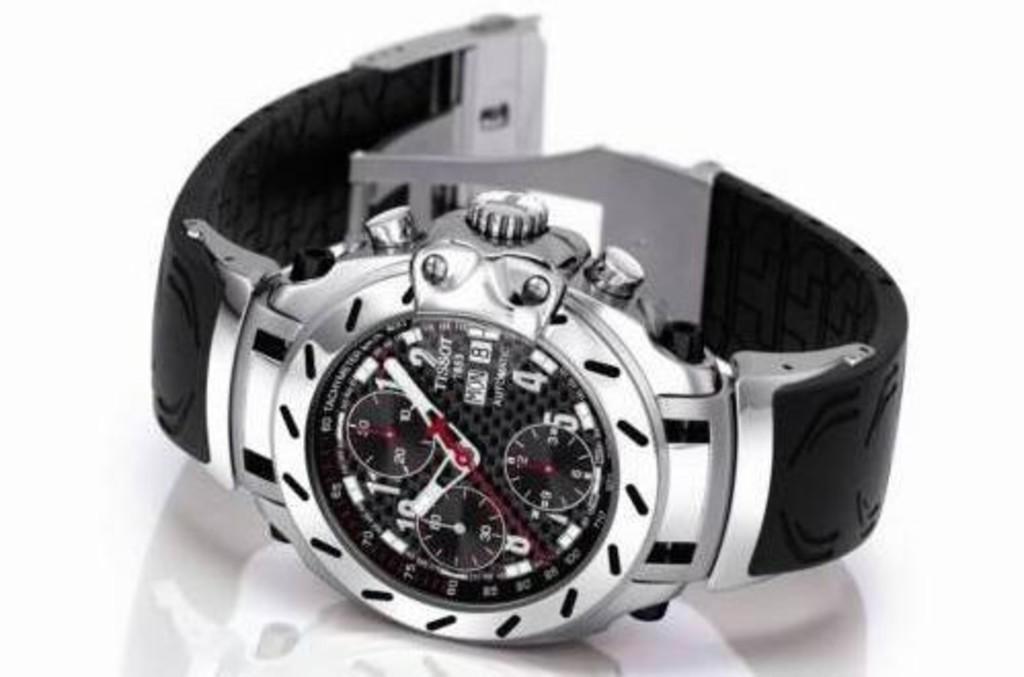What day of the week is it?
Offer a terse response. Monday. What brand of watch is this?
Provide a short and direct response. Tissot. 